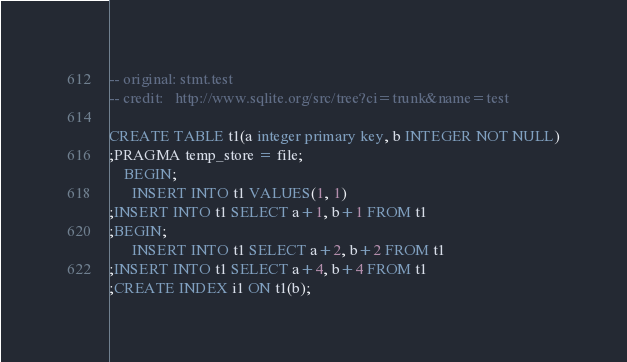<code> <loc_0><loc_0><loc_500><loc_500><_SQL_>-- original: stmt.test
-- credit:   http://www.sqlite.org/src/tree?ci=trunk&name=test

CREATE TABLE t1(a integer primary key, b INTEGER NOT NULL)
;PRAGMA temp_store = file;
    BEGIN;
      INSERT INTO t1 VALUES(1, 1)
;INSERT INTO t1 SELECT a+1, b+1 FROM t1
;BEGIN;
      INSERT INTO t1 SELECT a+2, b+2 FROM t1
;INSERT INTO t1 SELECT a+4, b+4 FROM t1
;CREATE INDEX i1 ON t1(b);</code> 